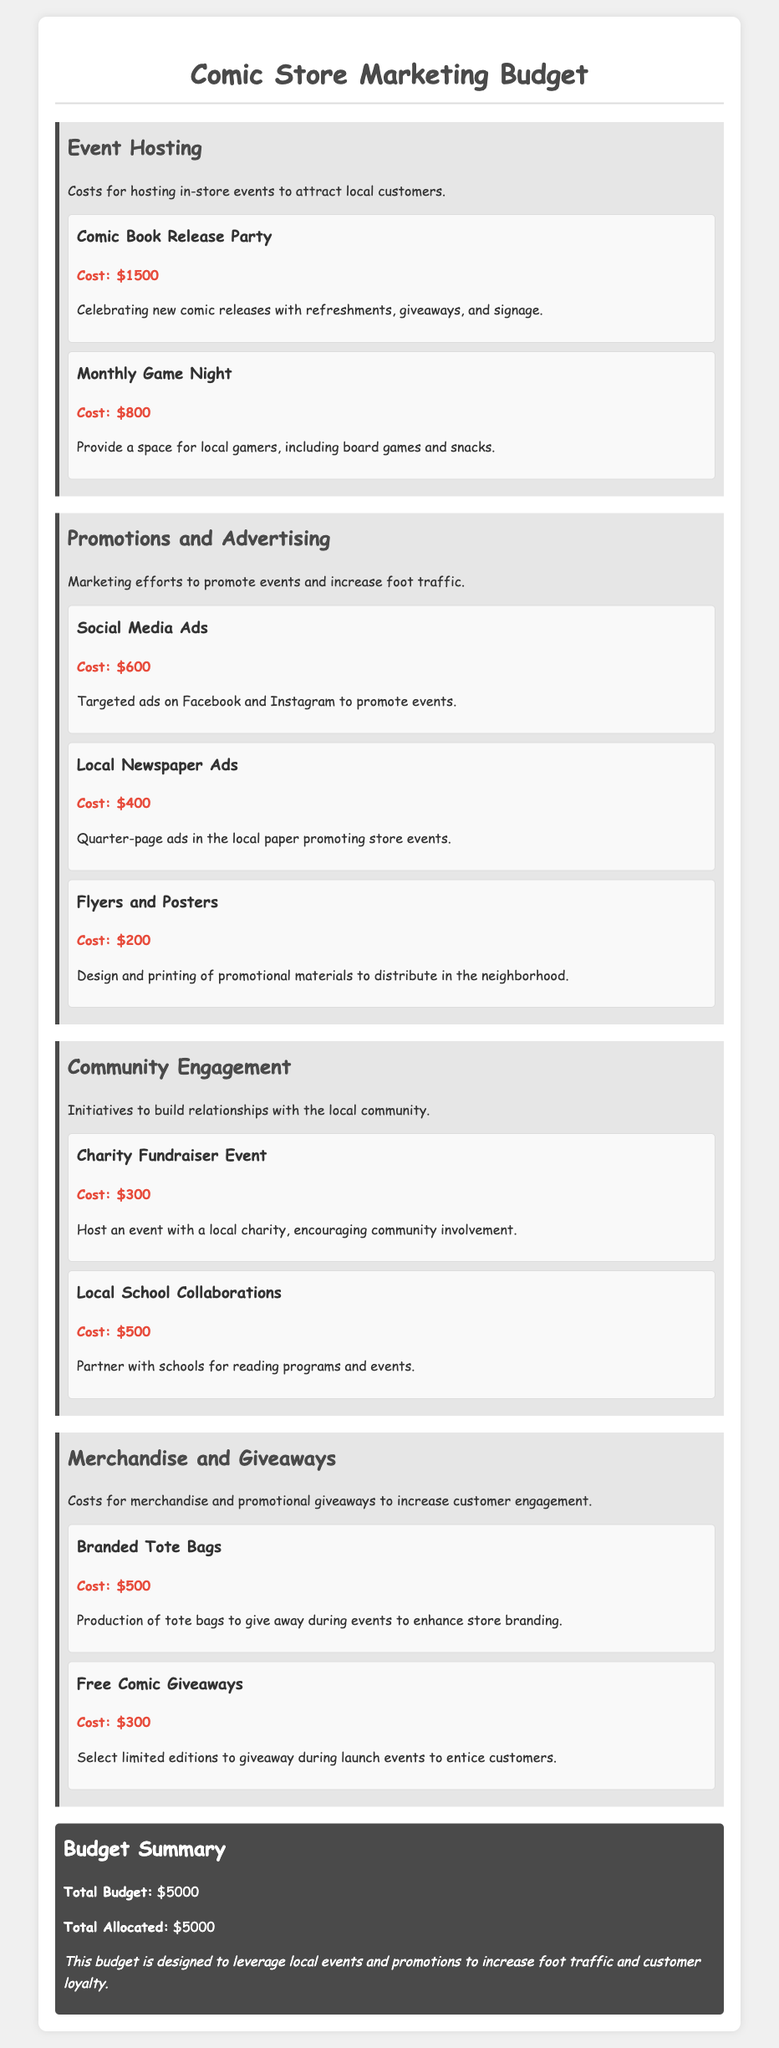What is the total budget? The total budget is stated clearly in the document’s summary section.
Answer: $5000 How much is allocated for the Comic Book Release Party? The document lists the cost specifically for the Comic Book Release Party under the Event Hosting category.
Answer: $1500 What is the cost for Social Media Ads? The cost for Social Media Ads is mentioned in the Promotions and Advertising section.
Answer: $600 Which event has a budget of $300? This refers to the Charity Fundraiser Event in the Community Engagement category.
Answer: Charity Fundraiser Event What is the total allocated amount? The total allocated amount is provided in the summary section of the document.
Answer: $5000 How many dollars are allocated for Free Comic Giveaways? This is specified in the Merchandise and Giveaways section of the budget.
Answer: $300 Which category has the highest total expenses? One needs to evaluate the costs listed across all categories to determine this.
Answer: Event Hosting How much is spent on Flyers and Posters? The individual item cost can be found in the Promotions and Advertising section.
Answer: $200 What type of merchandise is included for promotional purposes? The document specifies the types of merchandise under the Merchandise and Giveaways section.
Answer: Branded Tote Bags 